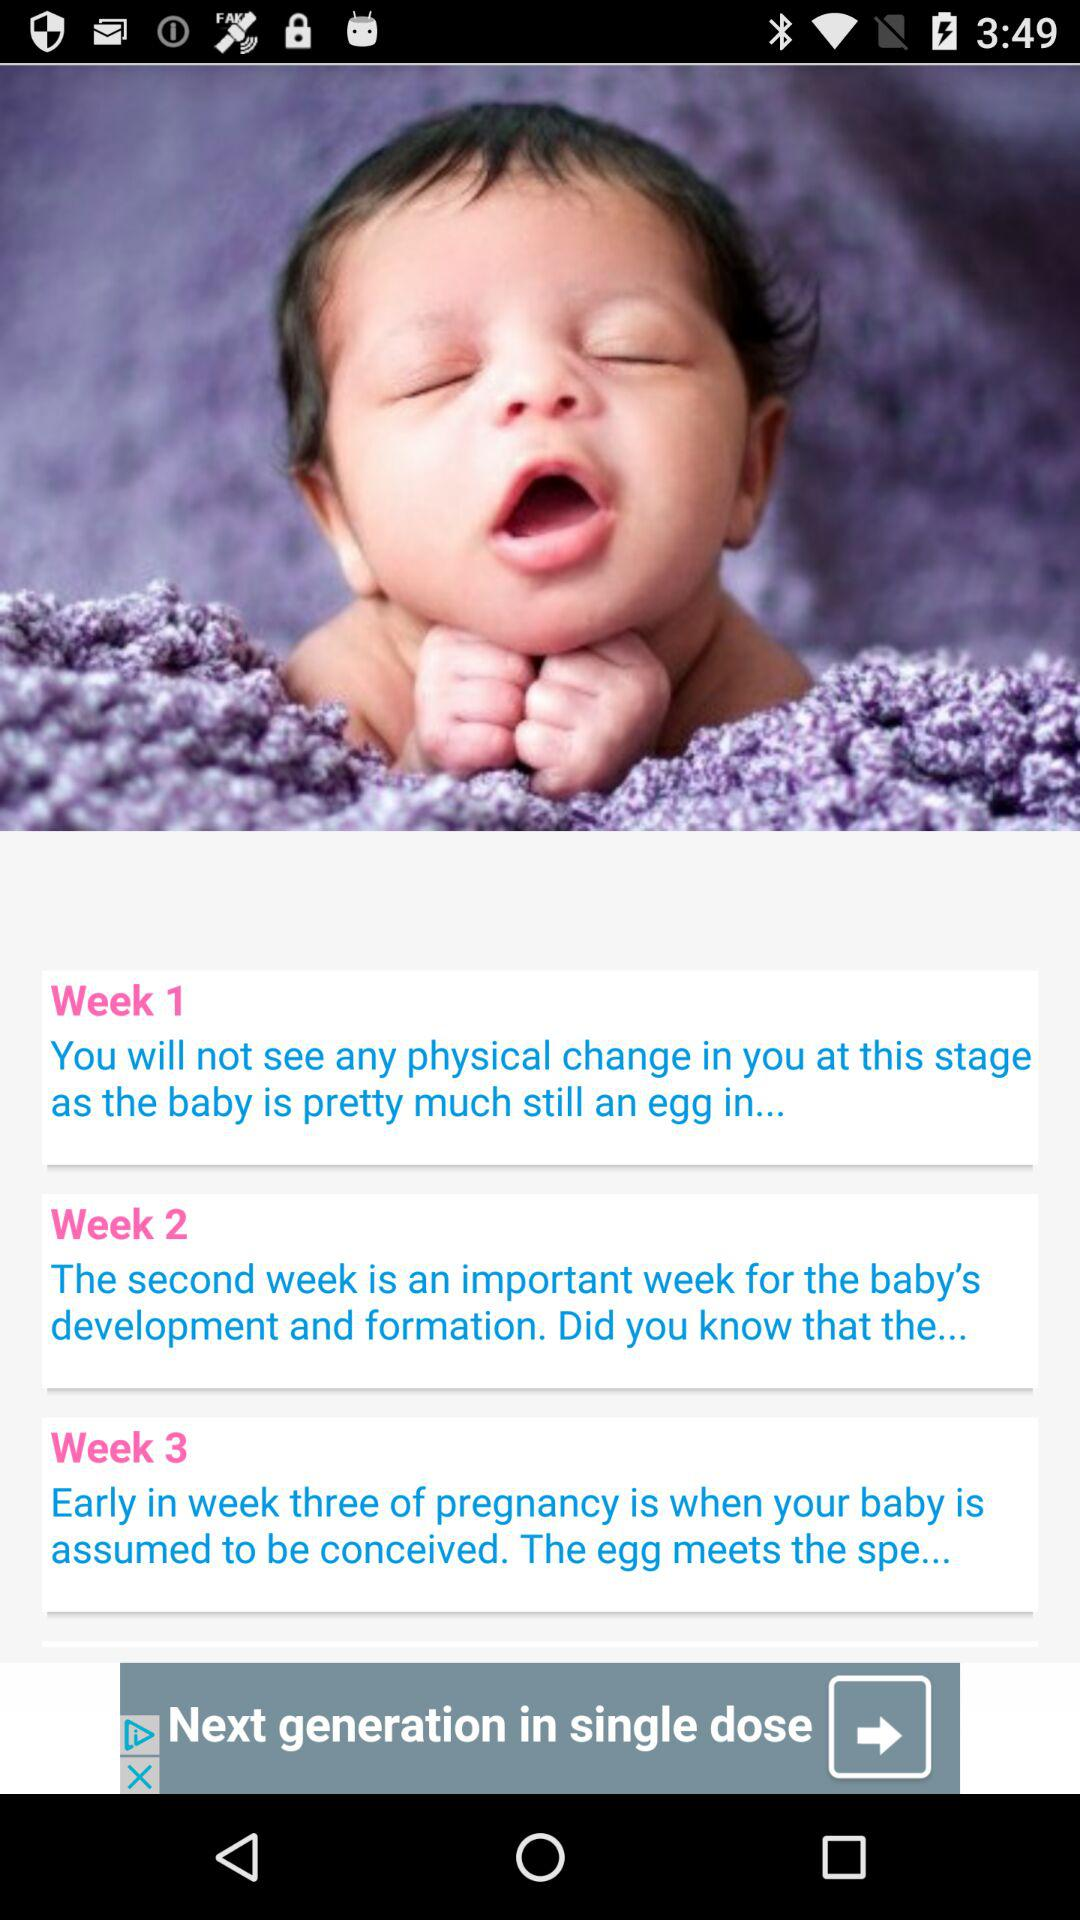Would we see any physical change in week 1? You will not see any physical change in week 1. 